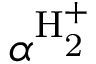<formula> <loc_0><loc_0><loc_500><loc_500>\alpha ^ { H _ { 2 } ^ { + } }</formula> 